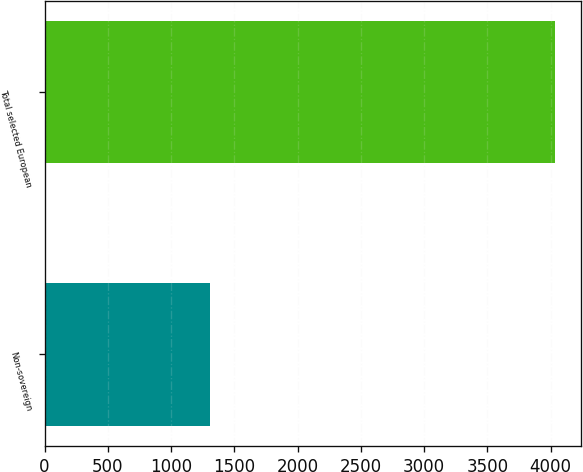Convert chart. <chart><loc_0><loc_0><loc_500><loc_500><bar_chart><fcel>Non-sovereign<fcel>Total selected European<nl><fcel>1310<fcel>4038<nl></chart> 